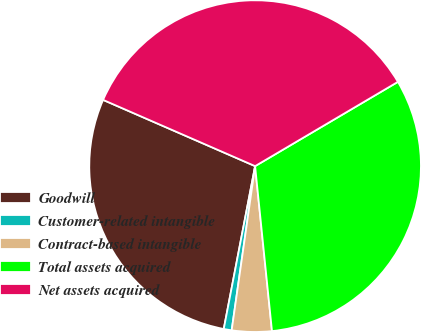Convert chart to OTSL. <chart><loc_0><loc_0><loc_500><loc_500><pie_chart><fcel>Goodwill<fcel>Customer-related intangible<fcel>Contract-based intangible<fcel>Total assets acquired<fcel>Net assets acquired<nl><fcel>28.51%<fcel>0.77%<fcel>3.88%<fcel>31.86%<fcel>34.97%<nl></chart> 